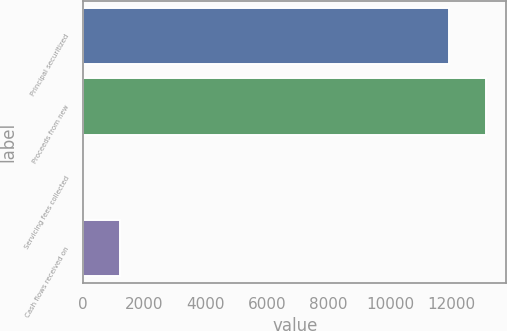Convert chart. <chart><loc_0><loc_0><loc_500><loc_500><bar_chart><fcel>Principal securitized<fcel>Proceeds from new<fcel>Servicing fees collected<fcel>Cash flows received on<nl><fcel>11933<fcel>13133.8<fcel>3<fcel>1203.8<nl></chart> 